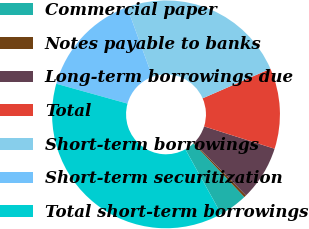Convert chart. <chart><loc_0><loc_0><loc_500><loc_500><pie_chart><fcel>Commercial paper<fcel>Notes payable to banks<fcel>Long-term borrowings due<fcel>Total<fcel>Short-term borrowings<fcel>Short-term securitization<fcel>Total short-term borrowings<nl><fcel>4.02%<fcel>0.32%<fcel>7.73%<fcel>11.44%<fcel>23.98%<fcel>15.14%<fcel>37.38%<nl></chart> 